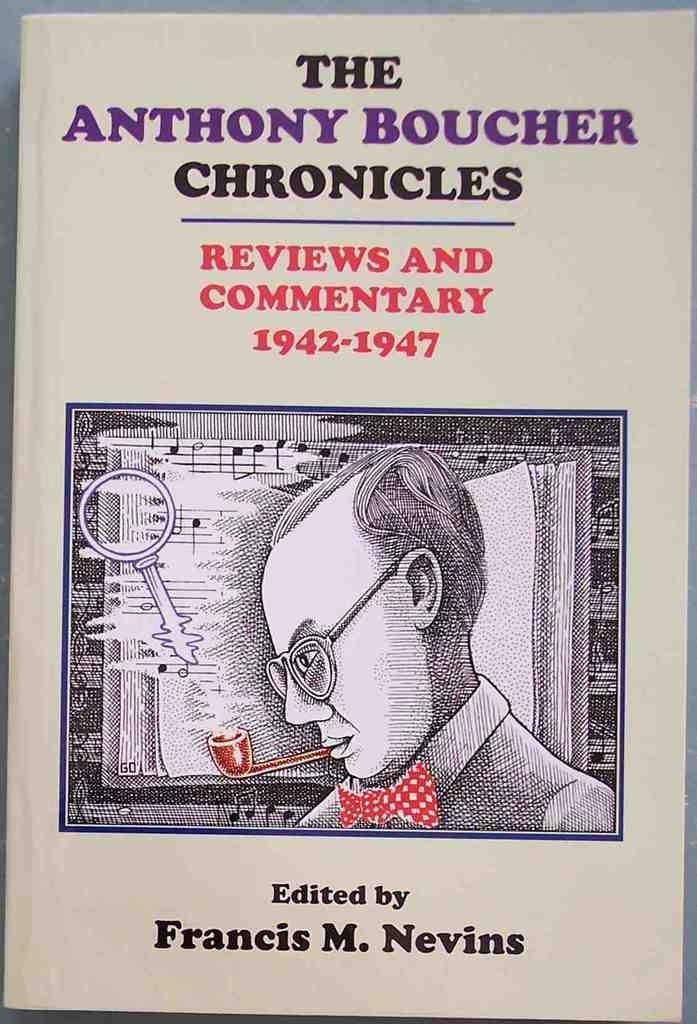<image>
Summarize the visual content of the image. Book cover showing a man with glasses smoking edited by Francis M. Nevins. 